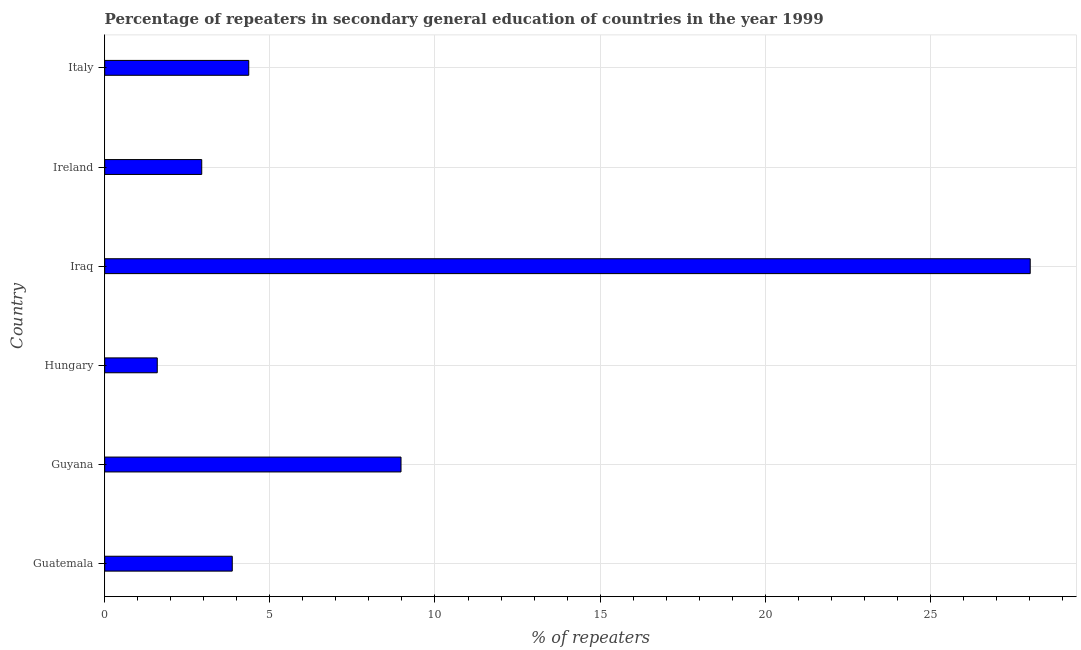Does the graph contain grids?
Make the answer very short. Yes. What is the title of the graph?
Make the answer very short. Percentage of repeaters in secondary general education of countries in the year 1999. What is the label or title of the X-axis?
Ensure brevity in your answer.  % of repeaters. What is the label or title of the Y-axis?
Your answer should be very brief. Country. What is the percentage of repeaters in Iraq?
Offer a terse response. 28.02. Across all countries, what is the maximum percentage of repeaters?
Your answer should be compact. 28.02. Across all countries, what is the minimum percentage of repeaters?
Keep it short and to the point. 1.59. In which country was the percentage of repeaters maximum?
Provide a short and direct response. Iraq. In which country was the percentage of repeaters minimum?
Offer a terse response. Hungary. What is the sum of the percentage of repeaters?
Offer a terse response. 49.75. What is the difference between the percentage of repeaters in Guatemala and Italy?
Your answer should be very brief. -0.5. What is the average percentage of repeaters per country?
Your answer should be compact. 8.29. What is the median percentage of repeaters?
Ensure brevity in your answer.  4.11. What is the ratio of the percentage of repeaters in Iraq to that in Ireland?
Provide a succinct answer. 9.54. Is the percentage of repeaters in Iraq less than that in Italy?
Your response must be concise. No. What is the difference between the highest and the second highest percentage of repeaters?
Your answer should be very brief. 19.05. Is the sum of the percentage of repeaters in Guyana and Iraq greater than the maximum percentage of repeaters across all countries?
Offer a terse response. Yes. What is the difference between the highest and the lowest percentage of repeaters?
Offer a terse response. 26.43. Are all the bars in the graph horizontal?
Keep it short and to the point. Yes. How many countries are there in the graph?
Give a very brief answer. 6. What is the difference between two consecutive major ticks on the X-axis?
Offer a terse response. 5. What is the % of repeaters in Guatemala?
Provide a succinct answer. 3.86. What is the % of repeaters of Guyana?
Provide a short and direct response. 8.97. What is the % of repeaters in Hungary?
Provide a short and direct response. 1.59. What is the % of repeaters of Iraq?
Your response must be concise. 28.02. What is the % of repeaters in Ireland?
Your response must be concise. 2.94. What is the % of repeaters in Italy?
Make the answer very short. 4.36. What is the difference between the % of repeaters in Guatemala and Guyana?
Provide a short and direct response. -5.11. What is the difference between the % of repeaters in Guatemala and Hungary?
Provide a succinct answer. 2.27. What is the difference between the % of repeaters in Guatemala and Iraq?
Provide a short and direct response. -24.16. What is the difference between the % of repeaters in Guatemala and Ireland?
Your response must be concise. 0.92. What is the difference between the % of repeaters in Guatemala and Italy?
Your answer should be very brief. -0.5. What is the difference between the % of repeaters in Guyana and Hungary?
Ensure brevity in your answer.  7.38. What is the difference between the % of repeaters in Guyana and Iraq?
Keep it short and to the point. -19.05. What is the difference between the % of repeaters in Guyana and Ireland?
Give a very brief answer. 6.03. What is the difference between the % of repeaters in Guyana and Italy?
Provide a short and direct response. 4.61. What is the difference between the % of repeaters in Hungary and Iraq?
Your answer should be compact. -26.43. What is the difference between the % of repeaters in Hungary and Ireland?
Offer a terse response. -1.35. What is the difference between the % of repeaters in Hungary and Italy?
Keep it short and to the point. -2.77. What is the difference between the % of repeaters in Iraq and Ireland?
Offer a very short reply. 25.09. What is the difference between the % of repeaters in Iraq and Italy?
Your response must be concise. 23.66. What is the difference between the % of repeaters in Ireland and Italy?
Keep it short and to the point. -1.42. What is the ratio of the % of repeaters in Guatemala to that in Guyana?
Give a very brief answer. 0.43. What is the ratio of the % of repeaters in Guatemala to that in Hungary?
Provide a short and direct response. 2.43. What is the ratio of the % of repeaters in Guatemala to that in Iraq?
Make the answer very short. 0.14. What is the ratio of the % of repeaters in Guatemala to that in Ireland?
Offer a very short reply. 1.31. What is the ratio of the % of repeaters in Guatemala to that in Italy?
Your response must be concise. 0.89. What is the ratio of the % of repeaters in Guyana to that in Hungary?
Your answer should be very brief. 5.64. What is the ratio of the % of repeaters in Guyana to that in Iraq?
Give a very brief answer. 0.32. What is the ratio of the % of repeaters in Guyana to that in Ireland?
Make the answer very short. 3.05. What is the ratio of the % of repeaters in Guyana to that in Italy?
Provide a succinct answer. 2.06. What is the ratio of the % of repeaters in Hungary to that in Iraq?
Offer a very short reply. 0.06. What is the ratio of the % of repeaters in Hungary to that in Ireland?
Give a very brief answer. 0.54. What is the ratio of the % of repeaters in Hungary to that in Italy?
Provide a short and direct response. 0.36. What is the ratio of the % of repeaters in Iraq to that in Ireland?
Make the answer very short. 9.54. What is the ratio of the % of repeaters in Iraq to that in Italy?
Keep it short and to the point. 6.42. What is the ratio of the % of repeaters in Ireland to that in Italy?
Your answer should be compact. 0.67. 